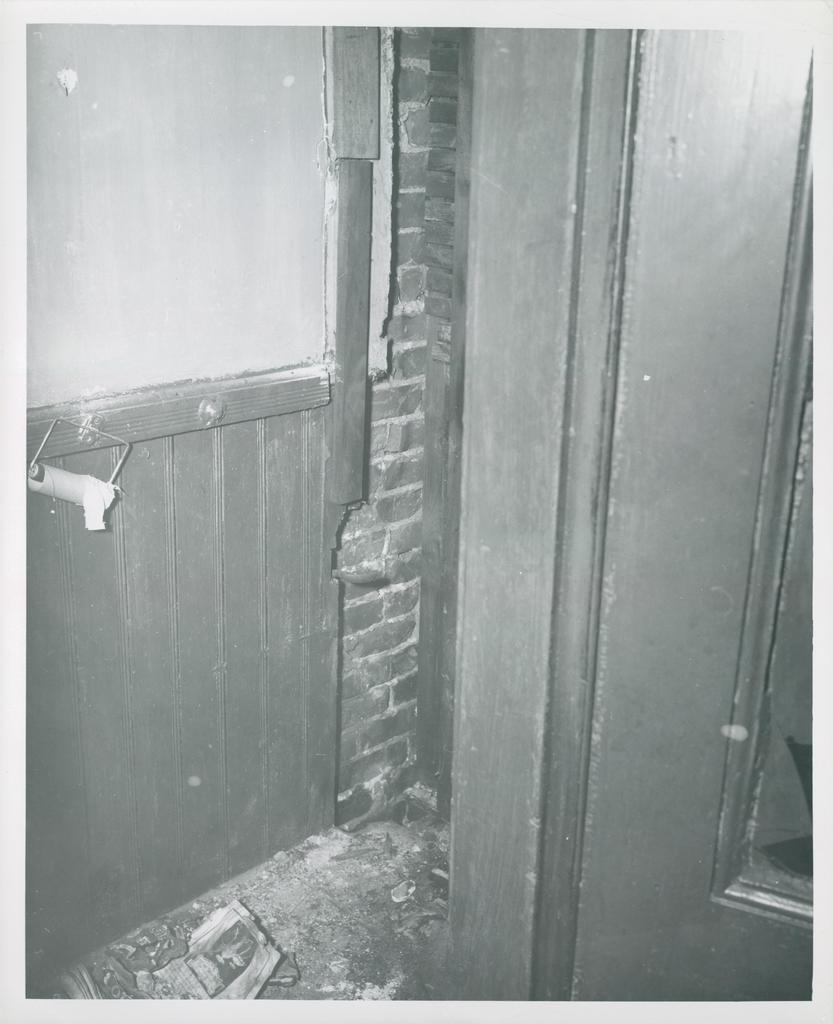What type of architectural feature can be seen in the image? There are doors in the image. What is the color scheme of the image? The image is a black and white photography. Can you see any icicles hanging from the doors in the image? There are no icicles present in the image, as it is a black and white photography of doors. 